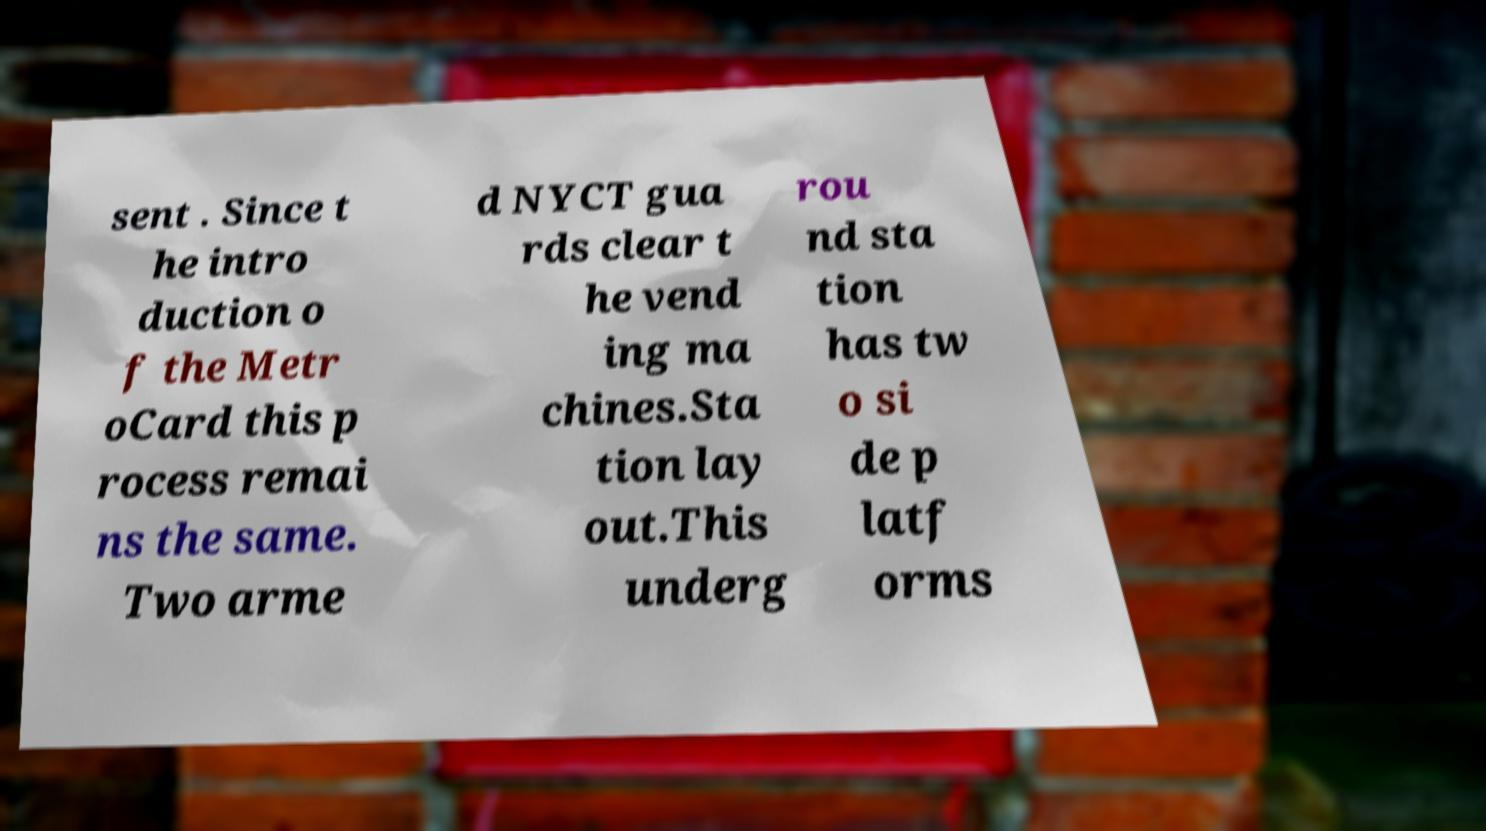For documentation purposes, I need the text within this image transcribed. Could you provide that? sent . Since t he intro duction o f the Metr oCard this p rocess remai ns the same. Two arme d NYCT gua rds clear t he vend ing ma chines.Sta tion lay out.This underg rou nd sta tion has tw o si de p latf orms 